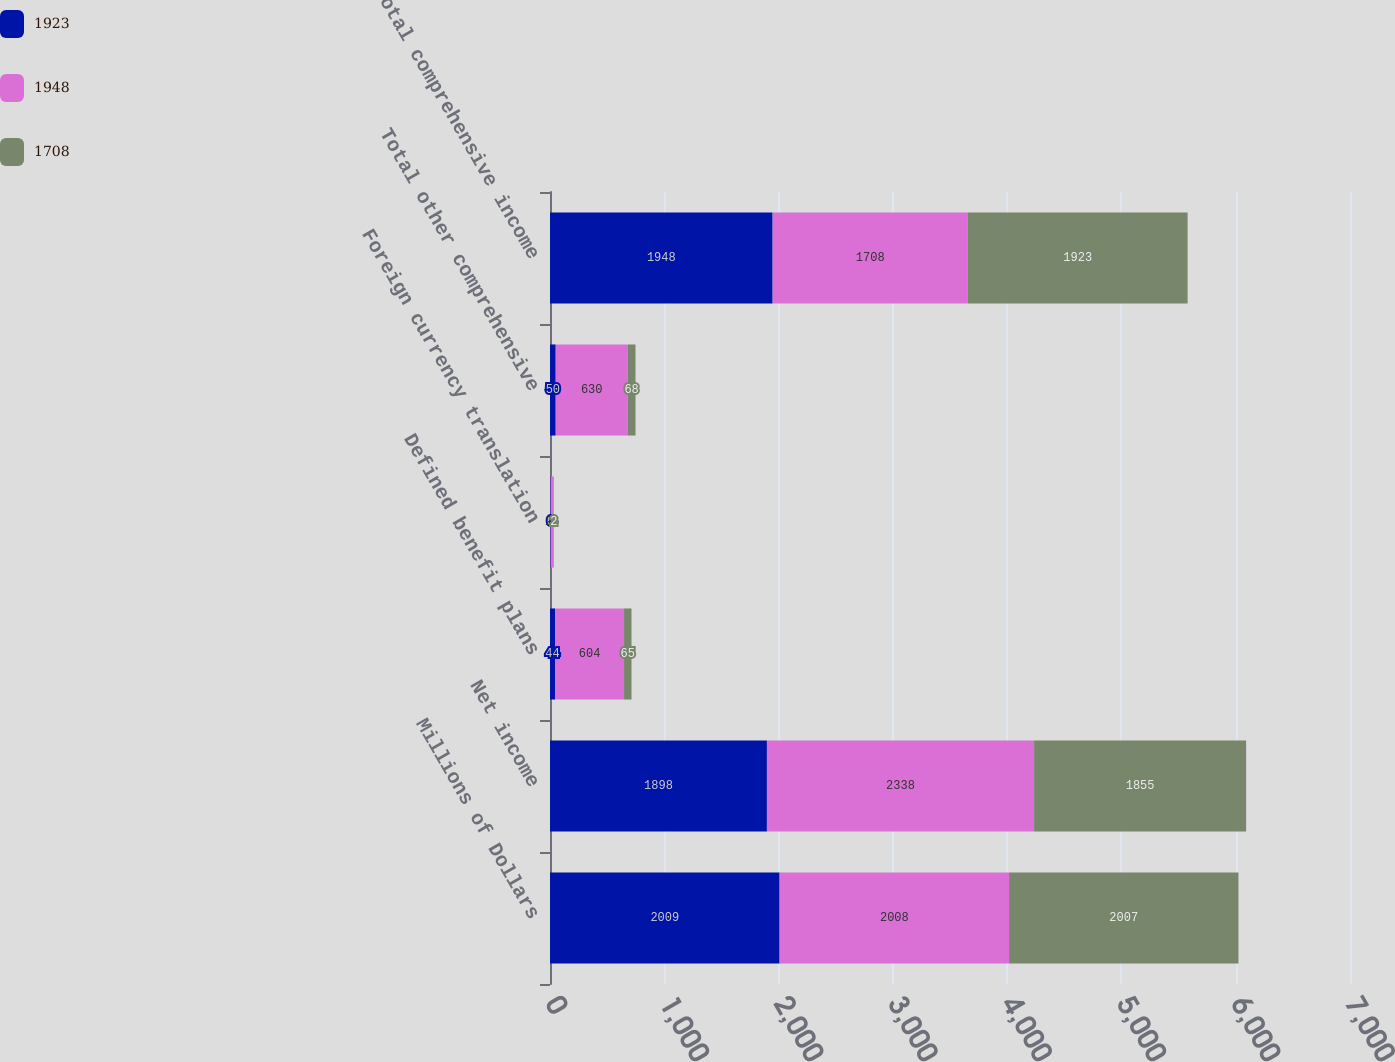Convert chart to OTSL. <chart><loc_0><loc_0><loc_500><loc_500><stacked_bar_chart><ecel><fcel>Millions of Dollars<fcel>Net income<fcel>Defined benefit plans<fcel>Foreign currency translation<fcel>Total other comprehensive<fcel>Total comprehensive income<nl><fcel>1923<fcel>2009<fcel>1898<fcel>44<fcel>6<fcel>50<fcel>1948<nl><fcel>1948<fcel>2008<fcel>2338<fcel>604<fcel>26<fcel>630<fcel>1708<nl><fcel>1708<fcel>2007<fcel>1855<fcel>65<fcel>2<fcel>68<fcel>1923<nl></chart> 